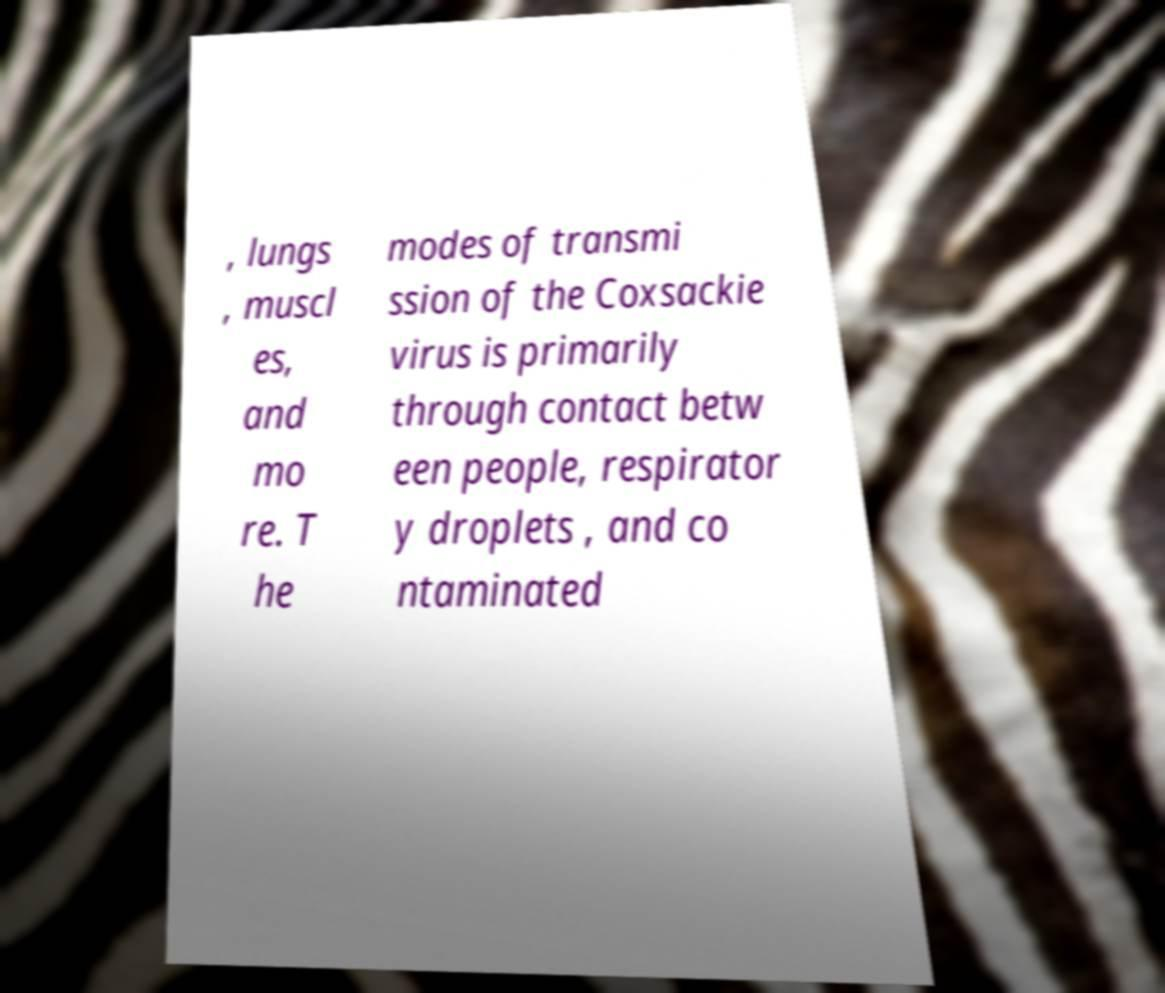What messages or text are displayed in this image? I need them in a readable, typed format. , lungs , muscl es, and mo re. T he modes of transmi ssion of the Coxsackie virus is primarily through contact betw een people, respirator y droplets , and co ntaminated 